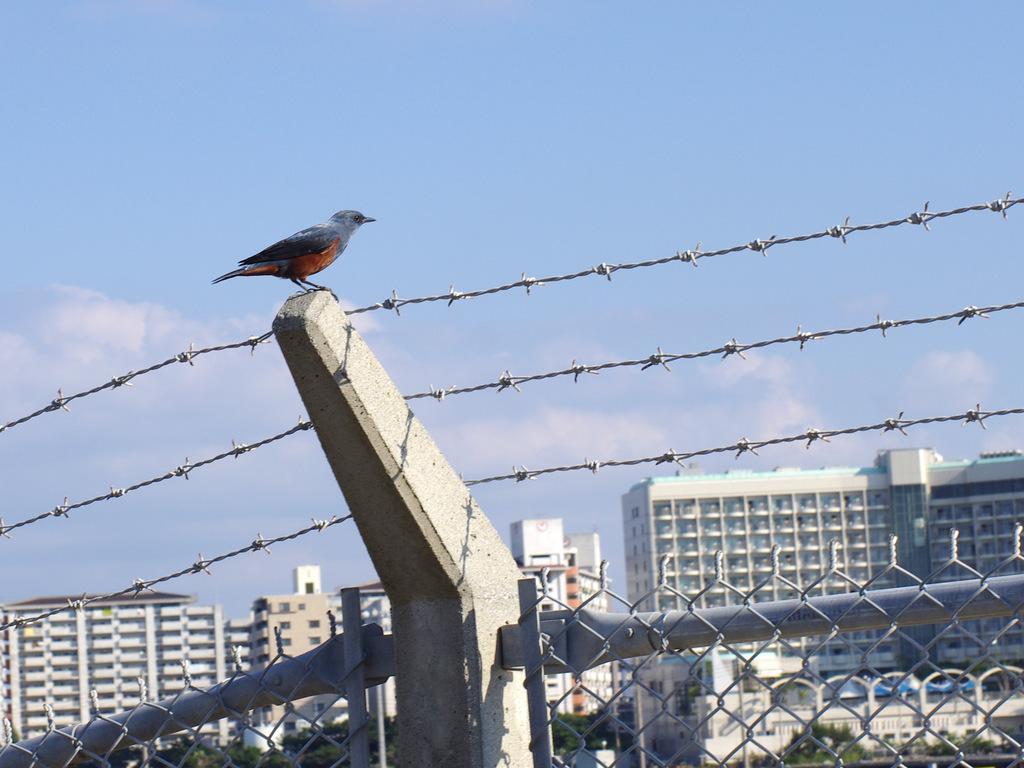Could you give a brief overview of what you see in this image? In this image I see the fencing over here and on this stone I see a bird. In the background I see the buildings, trees and the clear sky. 